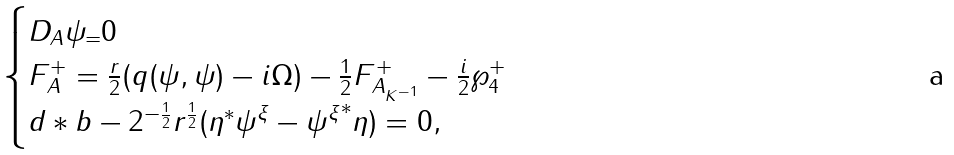Convert formula to latex. <formula><loc_0><loc_0><loc_500><loc_500>\begin{cases} D _ { A } \psi _ { = } 0 \\ F _ { A } ^ { + } = \frac { r } { 2 } ( q ( \psi , \psi ) - i \Omega ) - \frac { 1 } { 2 } F ^ { + } _ { A _ { K ^ { - 1 } } } - \frac { i } { 2 } \wp _ { 4 } ^ { + } \\ d * b - 2 ^ { - \frac { 1 } { 2 } } r ^ { \frac { 1 } { 2 } } ( \eta ^ { * } \psi ^ { \xi } - { \psi ^ { \xi } } ^ { * } \eta ) = 0 , \end{cases}</formula> 